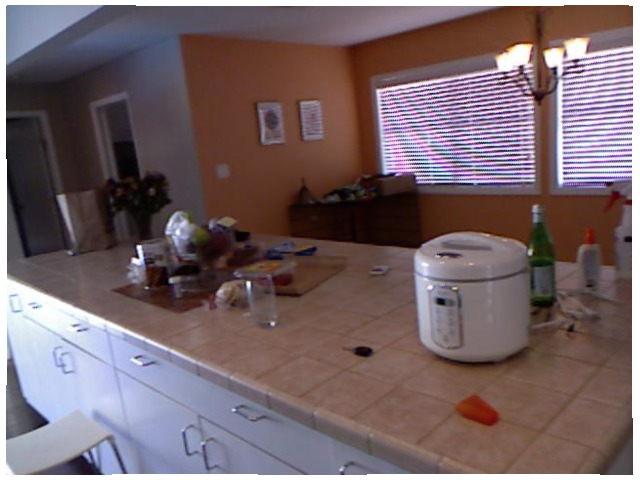<image>
Is the rice cooker under the glass? No. The rice cooker is not positioned under the glass. The vertical relationship between these objects is different. Is there a key on the counter? Yes. Looking at the image, I can see the key is positioned on top of the counter, with the counter providing support. Is the picture on the buffet? No. The picture is not positioned on the buffet. They may be near each other, but the picture is not supported by or resting on top of the buffet. 